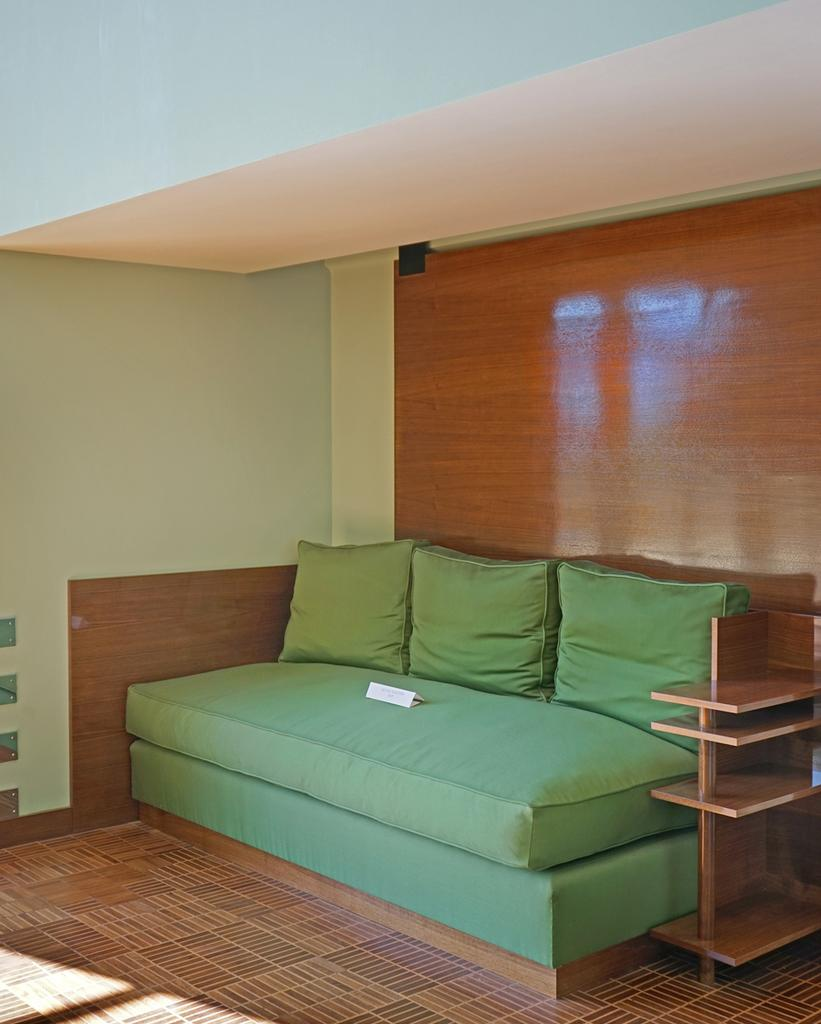What type of furniture is present in the room? There is a sofa in the room. What is the level of interest in the sofa among the people in the room? There is no information provided about the level of interest in the sofa among the people in the room. Is there any visible smoke in the room? There is no information provided about the presence of smoke in the room. 